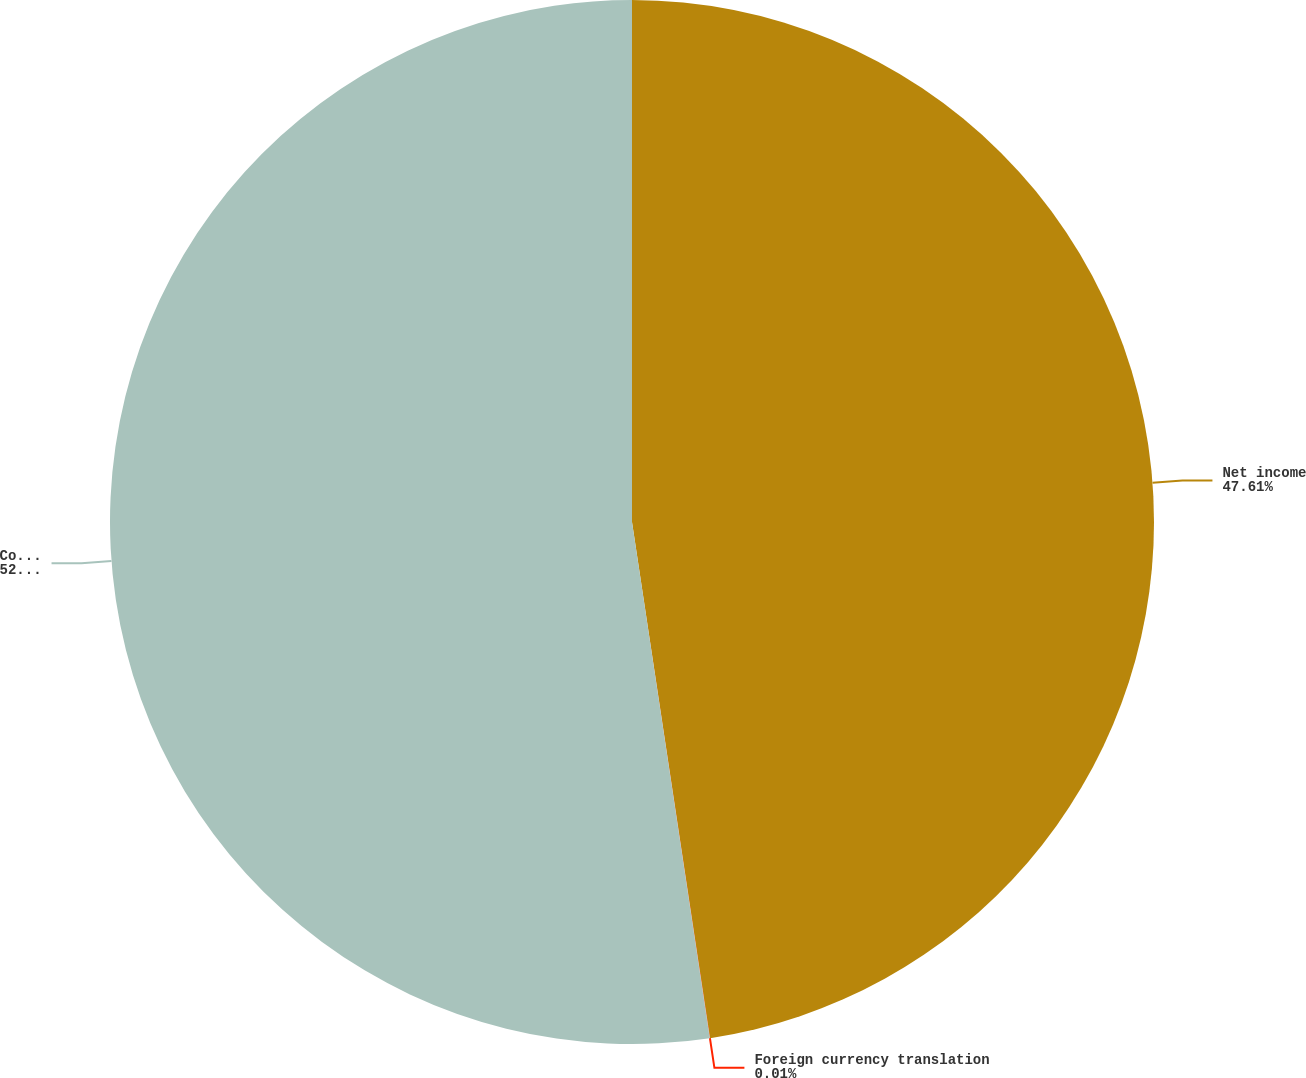Convert chart to OTSL. <chart><loc_0><loc_0><loc_500><loc_500><pie_chart><fcel>Net income<fcel>Foreign currency translation<fcel>Comprehensive income<nl><fcel>47.61%<fcel>0.01%<fcel>52.38%<nl></chart> 